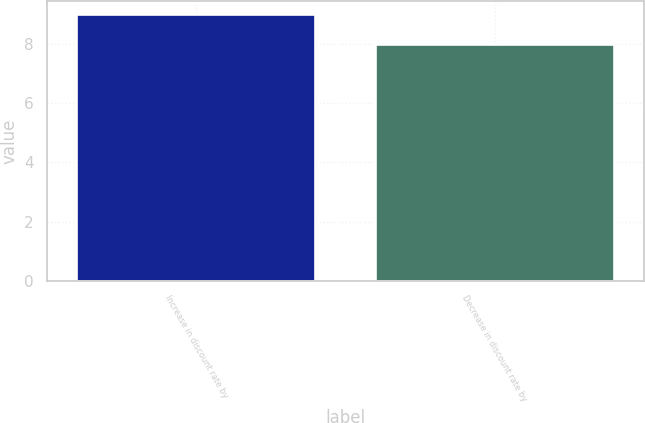<chart> <loc_0><loc_0><loc_500><loc_500><bar_chart><fcel>Increase in discount rate by<fcel>Decrease in discount rate by<nl><fcel>9<fcel>8<nl></chart> 